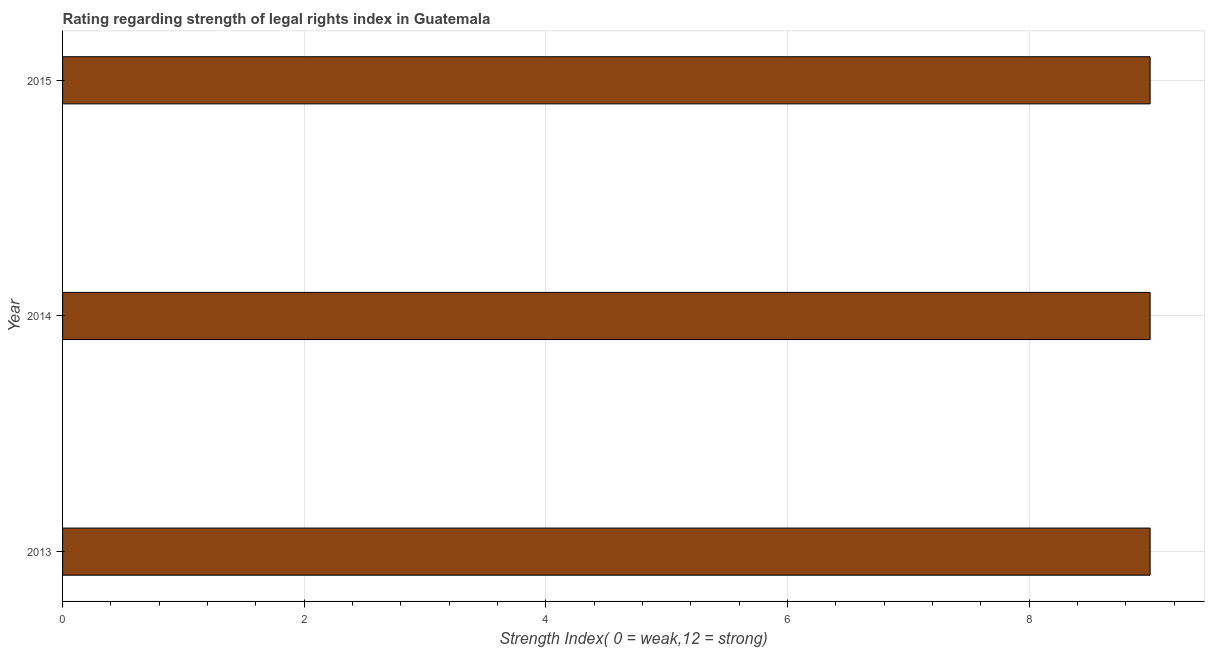Does the graph contain any zero values?
Give a very brief answer. No. What is the title of the graph?
Your response must be concise. Rating regarding strength of legal rights index in Guatemala. What is the label or title of the X-axis?
Offer a very short reply. Strength Index( 0 = weak,12 = strong). What is the label or title of the Y-axis?
Ensure brevity in your answer.  Year. What is the strength of legal rights index in 2013?
Your answer should be very brief. 9. Across all years, what is the maximum strength of legal rights index?
Provide a short and direct response. 9. Across all years, what is the minimum strength of legal rights index?
Your answer should be very brief. 9. In which year was the strength of legal rights index minimum?
Ensure brevity in your answer.  2013. What is the sum of the strength of legal rights index?
Your answer should be compact. 27. What is the median strength of legal rights index?
Offer a terse response. 9. What is the ratio of the strength of legal rights index in 2013 to that in 2014?
Provide a succinct answer. 1. What is the difference between the highest and the second highest strength of legal rights index?
Provide a short and direct response. 0. Is the sum of the strength of legal rights index in 2013 and 2015 greater than the maximum strength of legal rights index across all years?
Ensure brevity in your answer.  Yes. What is the difference between the highest and the lowest strength of legal rights index?
Your answer should be very brief. 0. How many years are there in the graph?
Offer a terse response. 3. What is the difference between two consecutive major ticks on the X-axis?
Your answer should be very brief. 2. What is the Strength Index( 0 = weak,12 = strong) of 2013?
Your answer should be compact. 9. What is the Strength Index( 0 = weak,12 = strong) in 2014?
Offer a terse response. 9. What is the difference between the Strength Index( 0 = weak,12 = strong) in 2014 and 2015?
Keep it short and to the point. 0. What is the ratio of the Strength Index( 0 = weak,12 = strong) in 2013 to that in 2014?
Your response must be concise. 1. What is the ratio of the Strength Index( 0 = weak,12 = strong) in 2014 to that in 2015?
Provide a succinct answer. 1. 